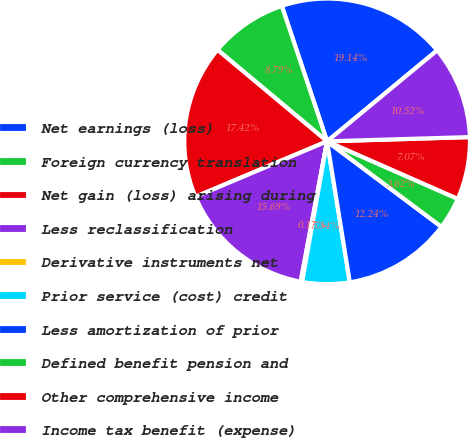Convert chart. <chart><loc_0><loc_0><loc_500><loc_500><pie_chart><fcel>Net earnings (loss)<fcel>Foreign currency translation<fcel>Net gain (loss) arising during<fcel>Less reclassification<fcel>Derivative instruments net<fcel>Prior service (cost) credit<fcel>Less amortization of prior<fcel>Defined benefit pension and<fcel>Other comprehensive income<fcel>Income tax benefit (expense)<nl><fcel>19.14%<fcel>8.79%<fcel>17.42%<fcel>15.69%<fcel>0.17%<fcel>5.34%<fcel>12.24%<fcel>3.62%<fcel>7.07%<fcel>10.52%<nl></chart> 